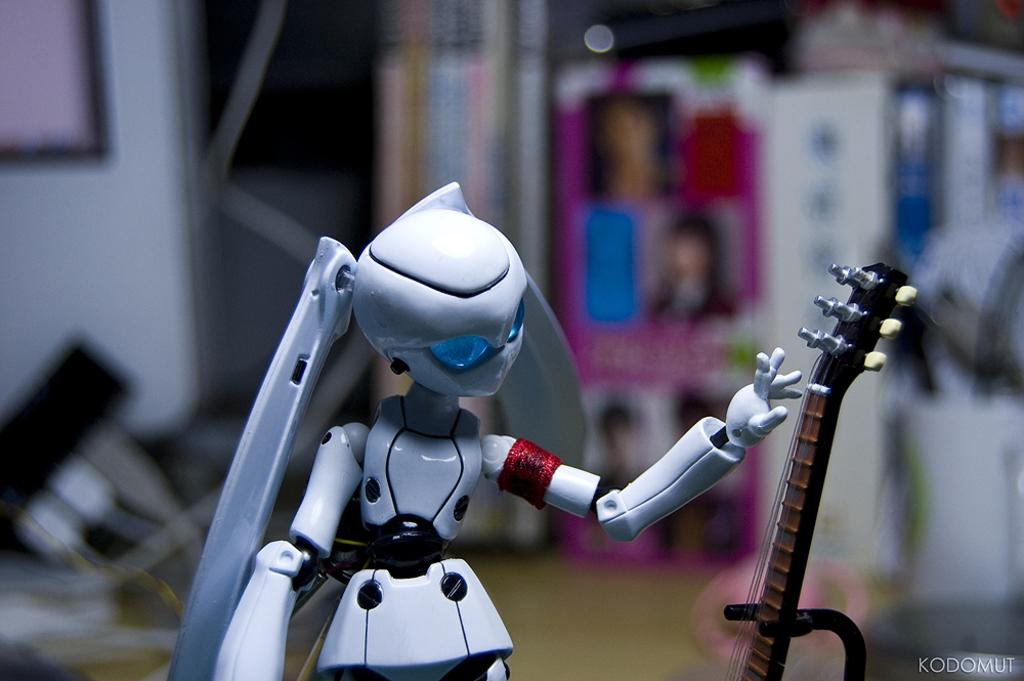What type of toy is present in the image? There is a toy of a girl in the image. What other object can be seen in the image? There is a stand for a musical instrument in the image. On which side of the image is the musical instrument stand located? The musical instrument stand is on the right side of the image. What can be found in the right corner of the image? There is some text written in the right corner of the image. What type of hair is visible on the toy in the image? The toy in the image is not a real person, so there is no hair visible on it. 